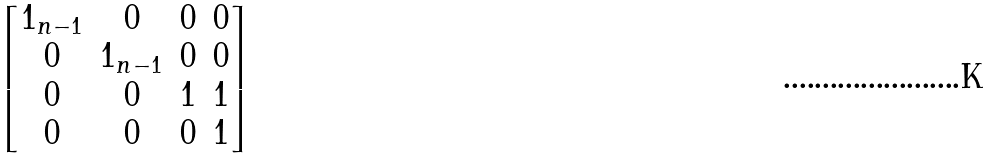Convert formula to latex. <formula><loc_0><loc_0><loc_500><loc_500>\begin{bmatrix} 1 _ { n - 1 } & 0 & 0 & 0 \\ 0 & 1 _ { n - 1 } & 0 & 0 \\ 0 & 0 & 1 & 1 \\ 0 & 0 & 0 & 1 \end{bmatrix}</formula> 